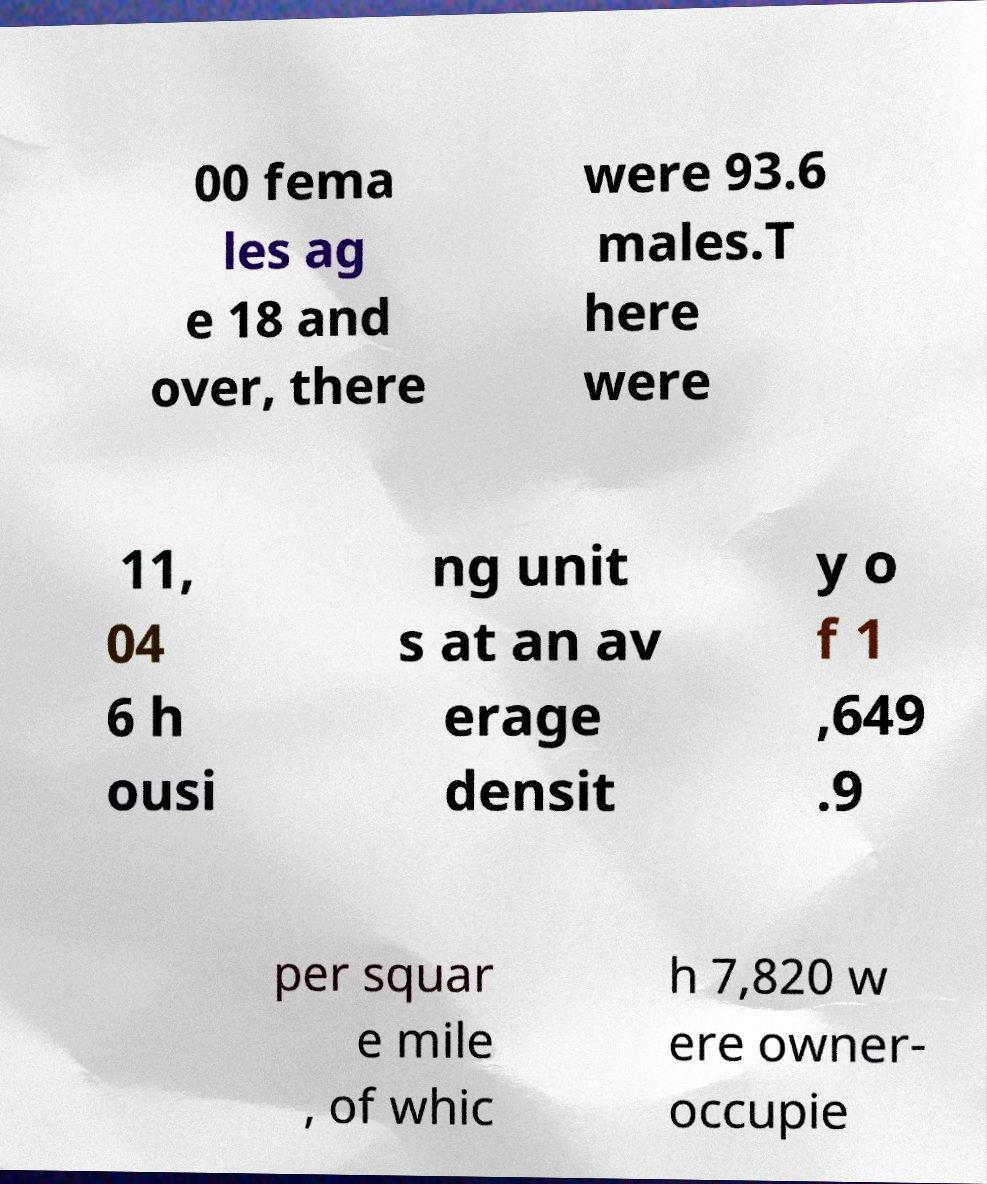Please read and relay the text visible in this image. What does it say? 00 fema les ag e 18 and over, there were 93.6 males.T here were 11, 04 6 h ousi ng unit s at an av erage densit y o f 1 ,649 .9 per squar e mile , of whic h 7,820 w ere owner- occupie 